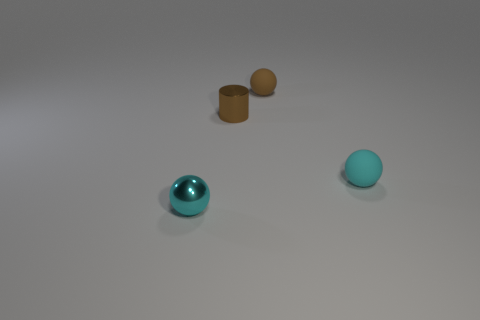Is there anything else that has the same size as the metal cylinder?
Offer a very short reply. Yes. There is a rubber sphere that is the same color as the small shiny sphere; what size is it?
Make the answer very short. Small. What is the brown cylinder made of?
Give a very brief answer. Metal. Is the material of the brown sphere the same as the cyan object that is to the left of the tiny cylinder?
Provide a short and direct response. No. What color is the tiny ball in front of the tiny cyan sphere on the right side of the tiny brown ball?
Your answer should be very brief. Cyan. How big is the ball that is on the left side of the small cyan matte sphere and in front of the brown metallic cylinder?
Provide a short and direct response. Small. What number of other things are the same shape as the brown metal thing?
Keep it short and to the point. 0. There is a brown metal object; is its shape the same as the small rubber object that is behind the tiny brown metallic thing?
Provide a short and direct response. No. How many small matte objects are left of the small metallic cylinder?
Your answer should be very brief. 0. Is there anything else that has the same material as the small brown cylinder?
Ensure brevity in your answer.  Yes. 